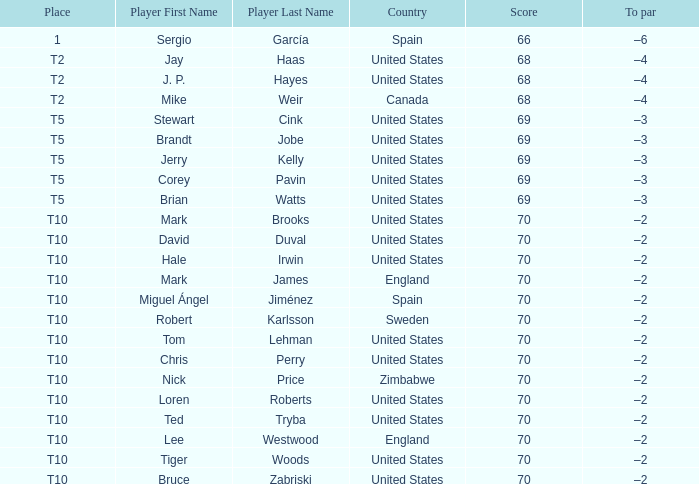What place did player mark brooks take? T10. 